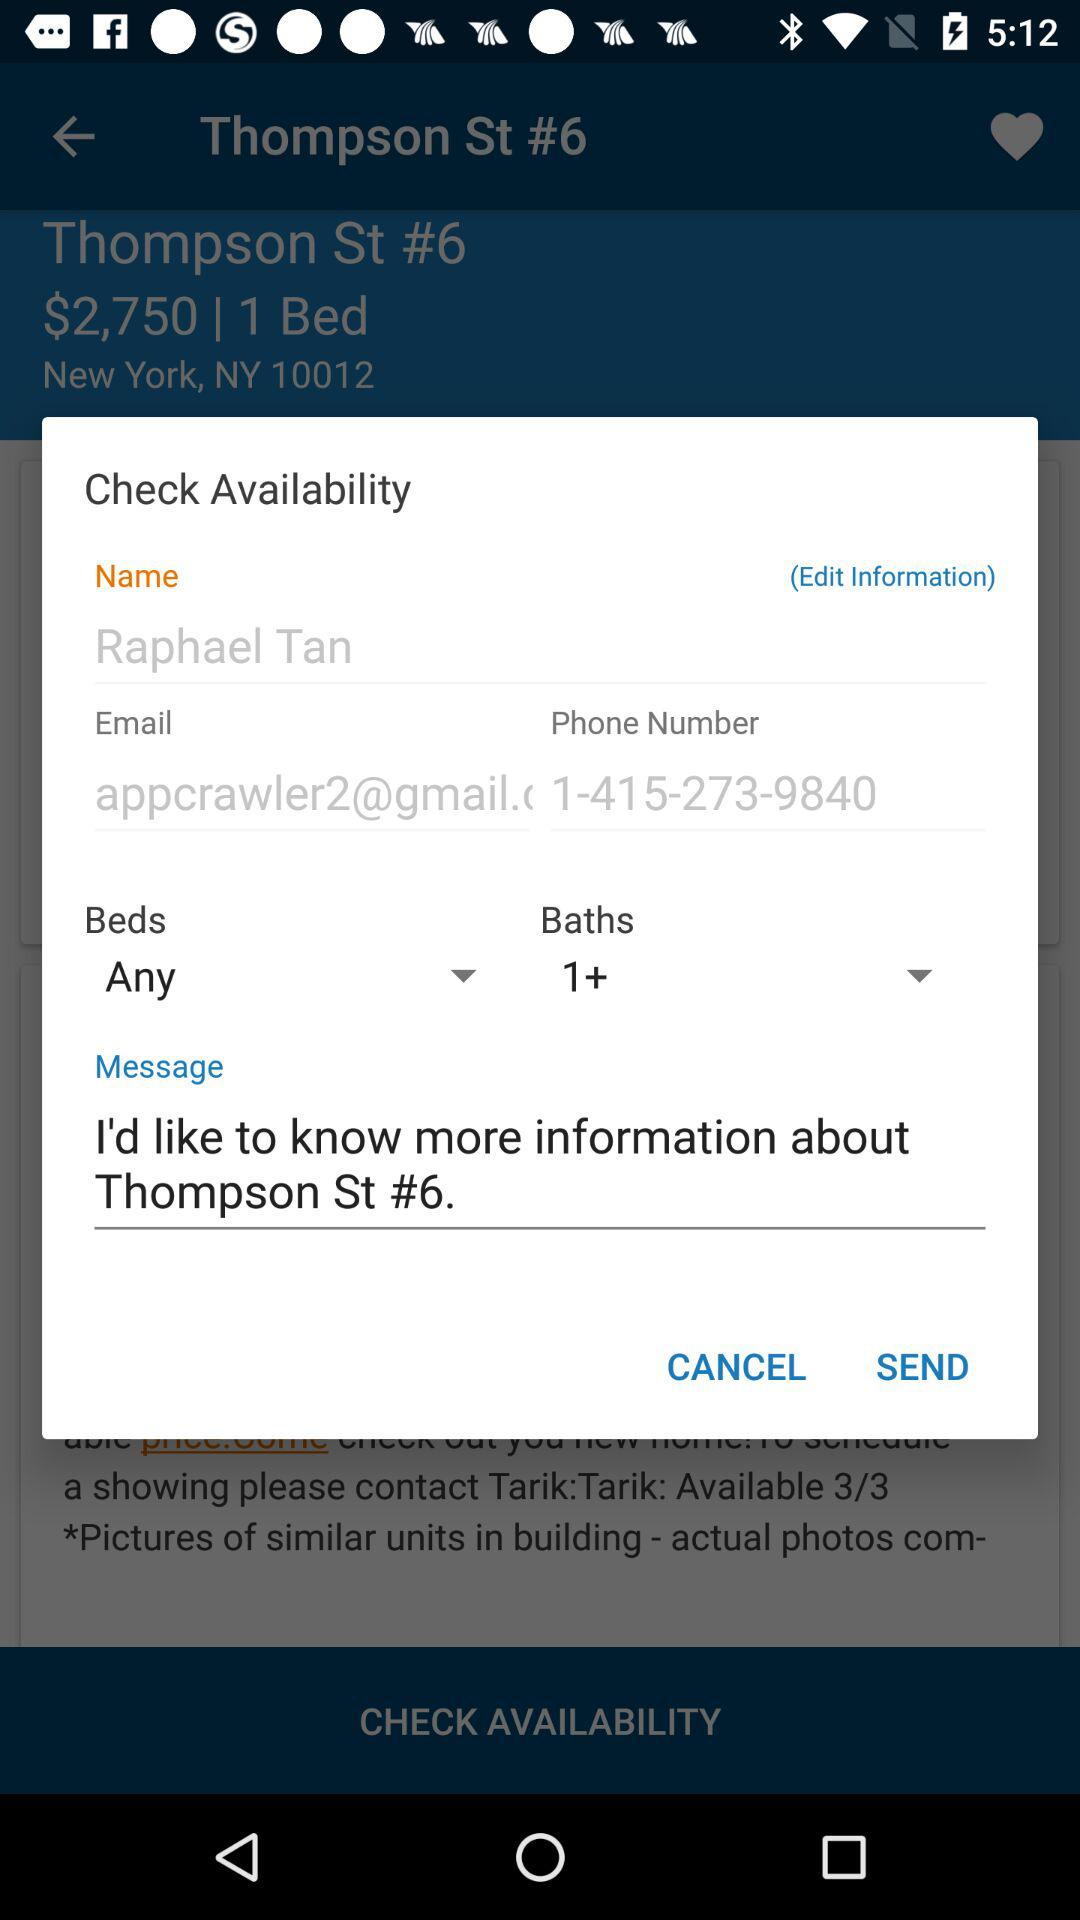What is the name? The name is Raphael Tan. 